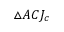Convert formula to latex. <formula><loc_0><loc_0><loc_500><loc_500>\triangle A C J _ { c }</formula> 